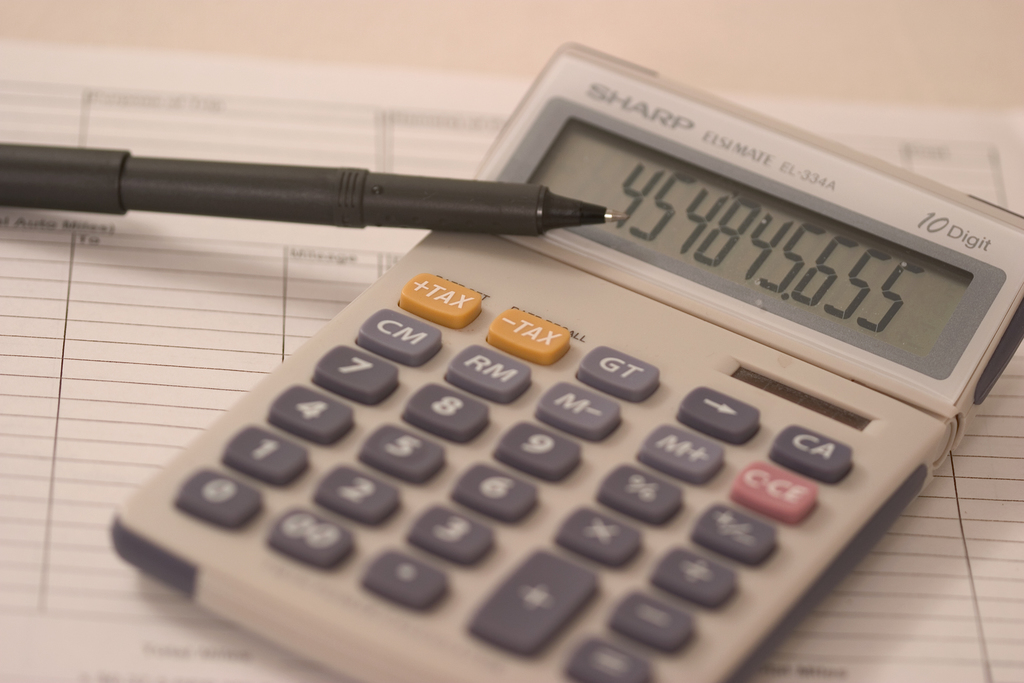What might the number 4548655 represent in this financial context? The number 4548655 displayed on the calculator could represent a variety of financial figures depending on the context, such as total revenue, expenses, or a balance from a specific transaction. Given the presence of a TAX key, it might particularly relate to computations for tax purposes, such as estimating tax liabilities or deductions in a business operation. 